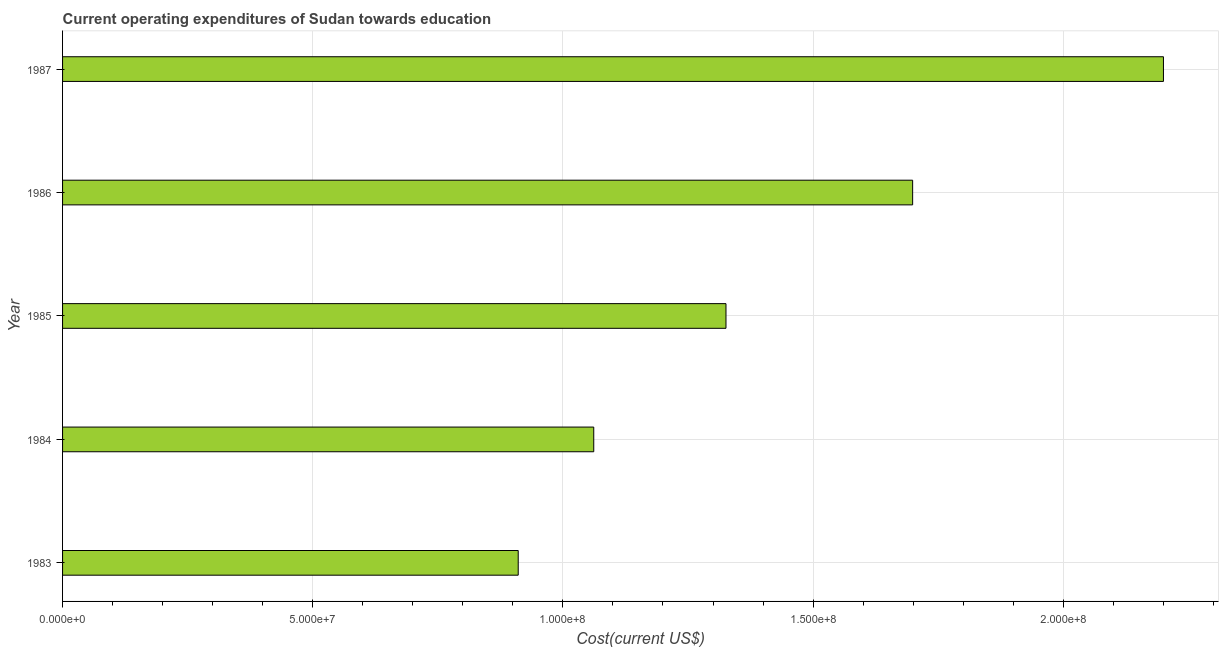Does the graph contain grids?
Offer a very short reply. Yes. What is the title of the graph?
Make the answer very short. Current operating expenditures of Sudan towards education. What is the label or title of the X-axis?
Keep it short and to the point. Cost(current US$). What is the label or title of the Y-axis?
Your response must be concise. Year. What is the education expenditure in 1987?
Provide a succinct answer. 2.20e+08. Across all years, what is the maximum education expenditure?
Provide a succinct answer. 2.20e+08. Across all years, what is the minimum education expenditure?
Your answer should be very brief. 9.11e+07. What is the sum of the education expenditure?
Provide a short and direct response. 7.20e+08. What is the difference between the education expenditure in 1984 and 1986?
Make the answer very short. -6.37e+07. What is the average education expenditure per year?
Ensure brevity in your answer.  1.44e+08. What is the median education expenditure?
Provide a succinct answer. 1.33e+08. In how many years, is the education expenditure greater than 210000000 US$?
Your answer should be very brief. 1. Do a majority of the years between 1986 and 1987 (inclusive) have education expenditure greater than 90000000 US$?
Ensure brevity in your answer.  Yes. What is the ratio of the education expenditure in 1983 to that in 1987?
Your response must be concise. 0.41. Is the education expenditure in 1985 less than that in 1986?
Give a very brief answer. Yes. What is the difference between the highest and the second highest education expenditure?
Give a very brief answer. 5.01e+07. What is the difference between the highest and the lowest education expenditure?
Provide a succinct answer. 1.29e+08. How many bars are there?
Give a very brief answer. 5. Are all the bars in the graph horizontal?
Ensure brevity in your answer.  Yes. Are the values on the major ticks of X-axis written in scientific E-notation?
Offer a terse response. Yes. What is the Cost(current US$) in 1983?
Your answer should be very brief. 9.11e+07. What is the Cost(current US$) of 1984?
Provide a short and direct response. 1.06e+08. What is the Cost(current US$) of 1985?
Keep it short and to the point. 1.33e+08. What is the Cost(current US$) of 1986?
Ensure brevity in your answer.  1.70e+08. What is the Cost(current US$) of 1987?
Offer a terse response. 2.20e+08. What is the difference between the Cost(current US$) in 1983 and 1984?
Keep it short and to the point. -1.51e+07. What is the difference between the Cost(current US$) in 1983 and 1985?
Your answer should be very brief. -4.15e+07. What is the difference between the Cost(current US$) in 1983 and 1986?
Offer a terse response. -7.88e+07. What is the difference between the Cost(current US$) in 1983 and 1987?
Provide a succinct answer. -1.29e+08. What is the difference between the Cost(current US$) in 1984 and 1985?
Provide a short and direct response. -2.64e+07. What is the difference between the Cost(current US$) in 1984 and 1986?
Keep it short and to the point. -6.37e+07. What is the difference between the Cost(current US$) in 1984 and 1987?
Provide a succinct answer. -1.14e+08. What is the difference between the Cost(current US$) in 1985 and 1986?
Provide a short and direct response. -3.73e+07. What is the difference between the Cost(current US$) in 1985 and 1987?
Provide a short and direct response. -8.74e+07. What is the difference between the Cost(current US$) in 1986 and 1987?
Ensure brevity in your answer.  -5.01e+07. What is the ratio of the Cost(current US$) in 1983 to that in 1984?
Your answer should be compact. 0.86. What is the ratio of the Cost(current US$) in 1983 to that in 1985?
Your answer should be compact. 0.69. What is the ratio of the Cost(current US$) in 1983 to that in 1986?
Your answer should be very brief. 0.54. What is the ratio of the Cost(current US$) in 1983 to that in 1987?
Offer a very short reply. 0.41. What is the ratio of the Cost(current US$) in 1984 to that in 1985?
Offer a very short reply. 0.8. What is the ratio of the Cost(current US$) in 1984 to that in 1986?
Offer a terse response. 0.62. What is the ratio of the Cost(current US$) in 1984 to that in 1987?
Your answer should be compact. 0.48. What is the ratio of the Cost(current US$) in 1985 to that in 1986?
Your answer should be compact. 0.78. What is the ratio of the Cost(current US$) in 1985 to that in 1987?
Ensure brevity in your answer.  0.6. What is the ratio of the Cost(current US$) in 1986 to that in 1987?
Offer a very short reply. 0.77. 